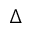Convert formula to latex. <formula><loc_0><loc_0><loc_500><loc_500>\Delta</formula> 